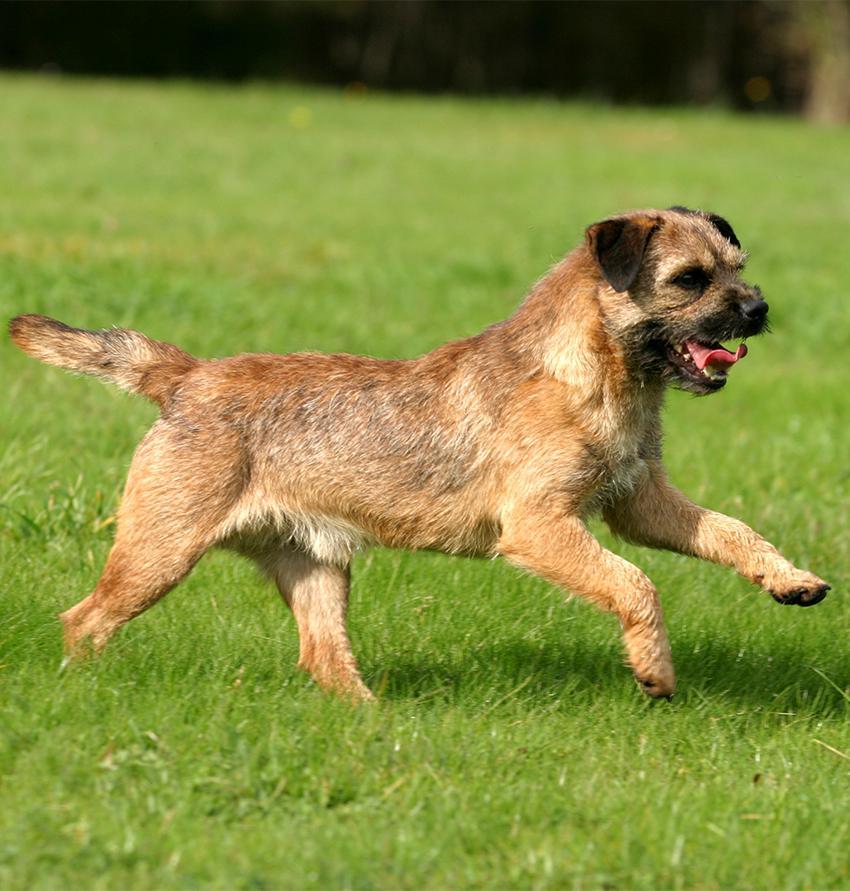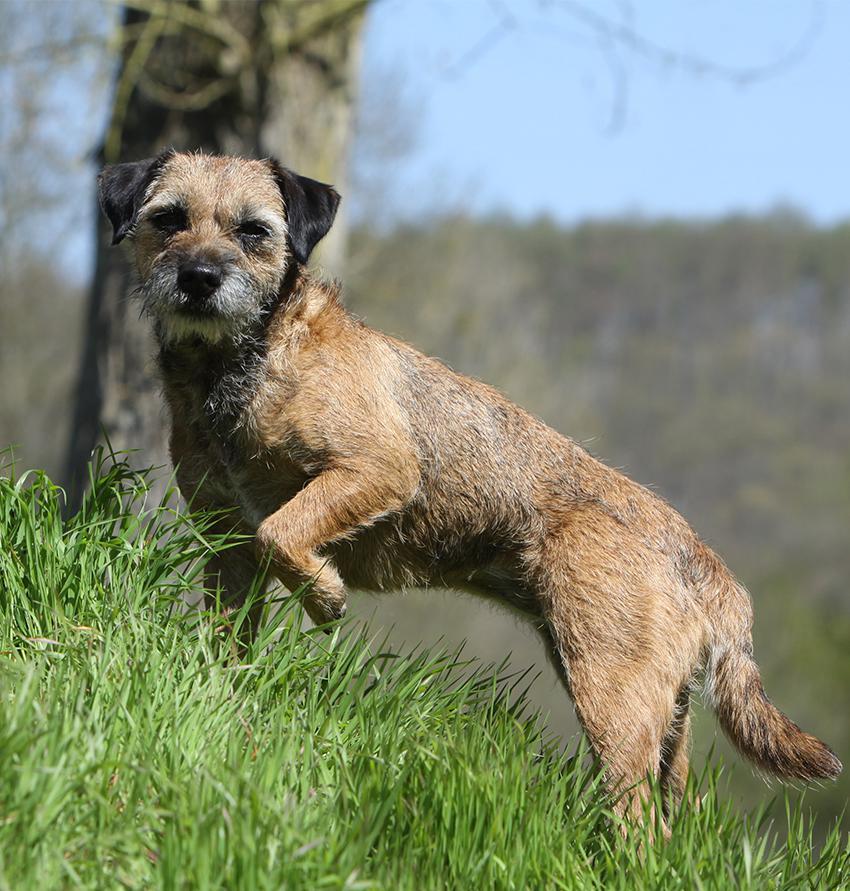The first image is the image on the left, the second image is the image on the right. Analyze the images presented: Is the assertion "The combined images include two dogs with bodies turned rightward in profile, and at least one dog with its head raised and gazing up to the right." valid? Answer yes or no. No. The first image is the image on the left, the second image is the image on the right. For the images shown, is this caption "A dog is standing on grass." true? Answer yes or no. Yes. 